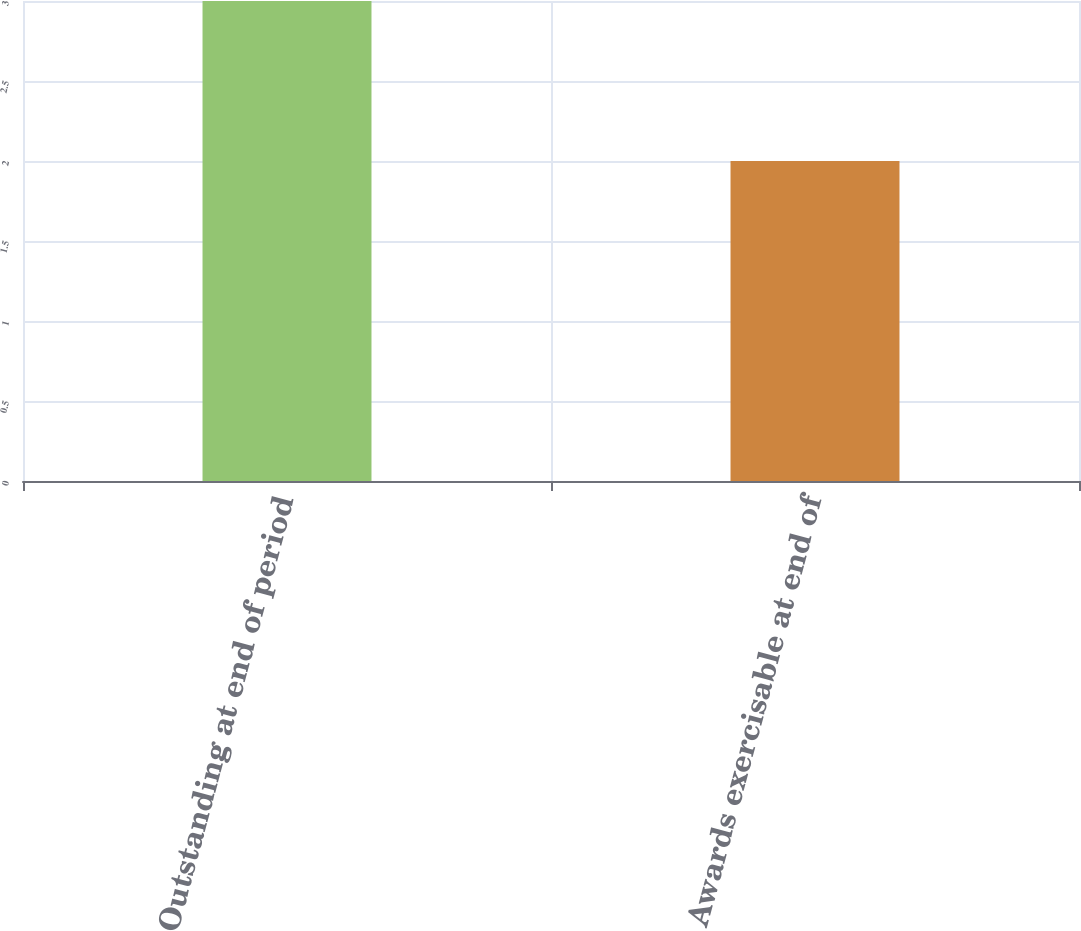Convert chart. <chart><loc_0><loc_0><loc_500><loc_500><bar_chart><fcel>Outstanding at end of period<fcel>Awards exercisable at end of<nl><fcel>3<fcel>2<nl></chart> 